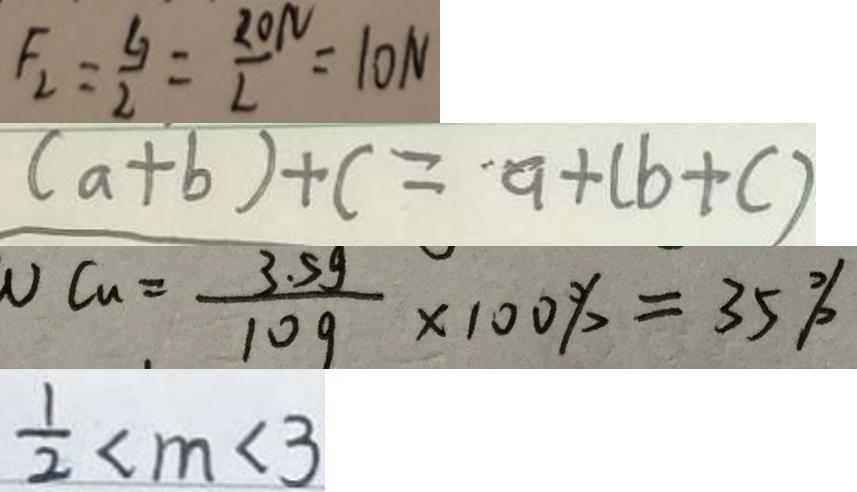Convert formula to latex. <formula><loc_0><loc_0><loc_500><loc_500>F _ { 2 } = \frac { G } { 2 } = \frac { 2 0 N } { 2 } = 1 0 N 
 ( a + b ) + c = a + ( b + c ) 
 v C u = \frac { 3 . 5 g } { 1 0 g } \times 1 0 0 \% = 3 5 \% 
 \frac { 1 } { 2 } < m < 3</formula> 